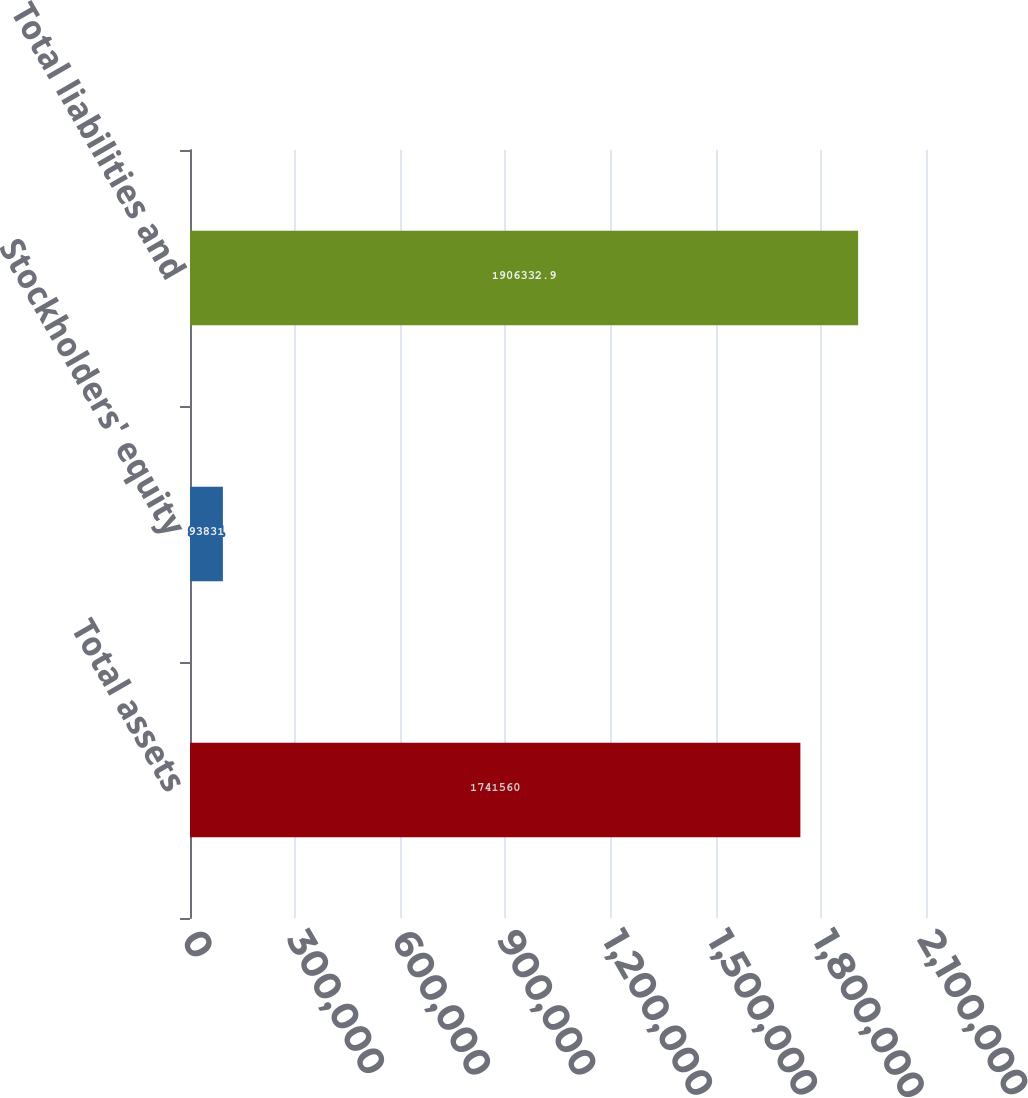Convert chart. <chart><loc_0><loc_0><loc_500><loc_500><bar_chart><fcel>Total assets<fcel>Stockholders' equity<fcel>Total liabilities and<nl><fcel>1.74156e+06<fcel>93831<fcel>1.90633e+06<nl></chart> 